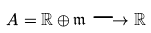<formula> <loc_0><loc_0><loc_500><loc_500>A = \mathbb { R } \oplus \mathfrak { m } \longrightarrow \mathbb { R }</formula> 